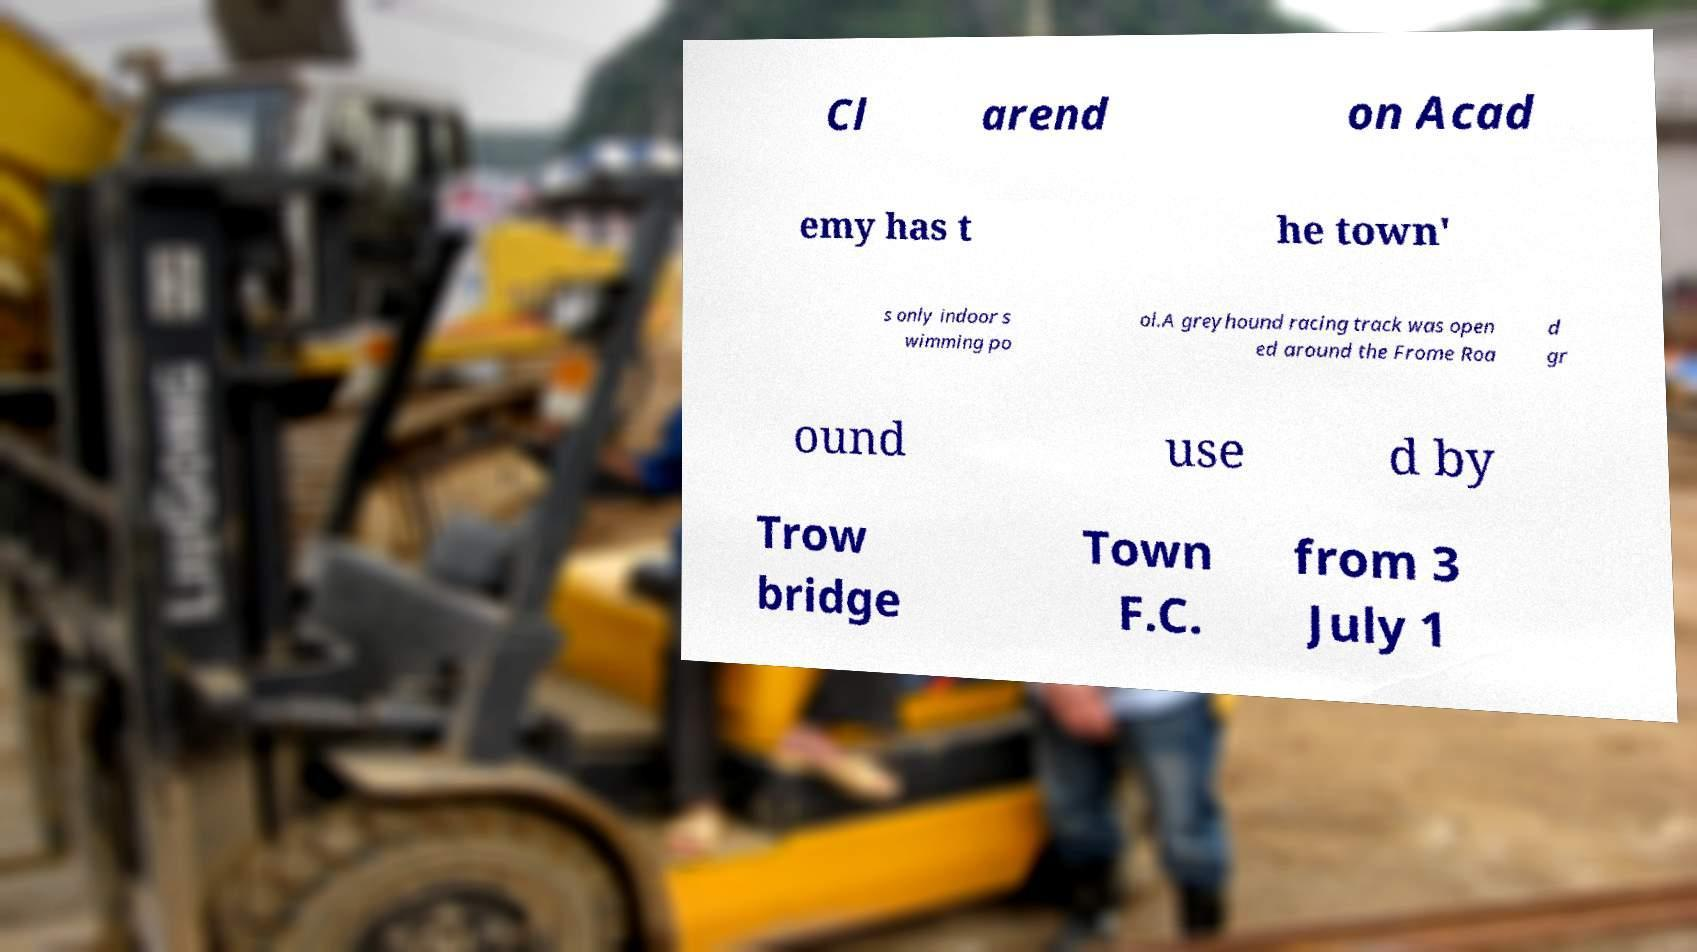Can you read and provide the text displayed in the image?This photo seems to have some interesting text. Can you extract and type it out for me? Cl arend on Acad emy has t he town' s only indoor s wimming po ol.A greyhound racing track was open ed around the Frome Roa d gr ound use d by Trow bridge Town F.C. from 3 July 1 